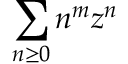Convert formula to latex. <formula><loc_0><loc_0><loc_500><loc_500>\sum _ { n \geq 0 } n ^ { m } z ^ { n }</formula> 